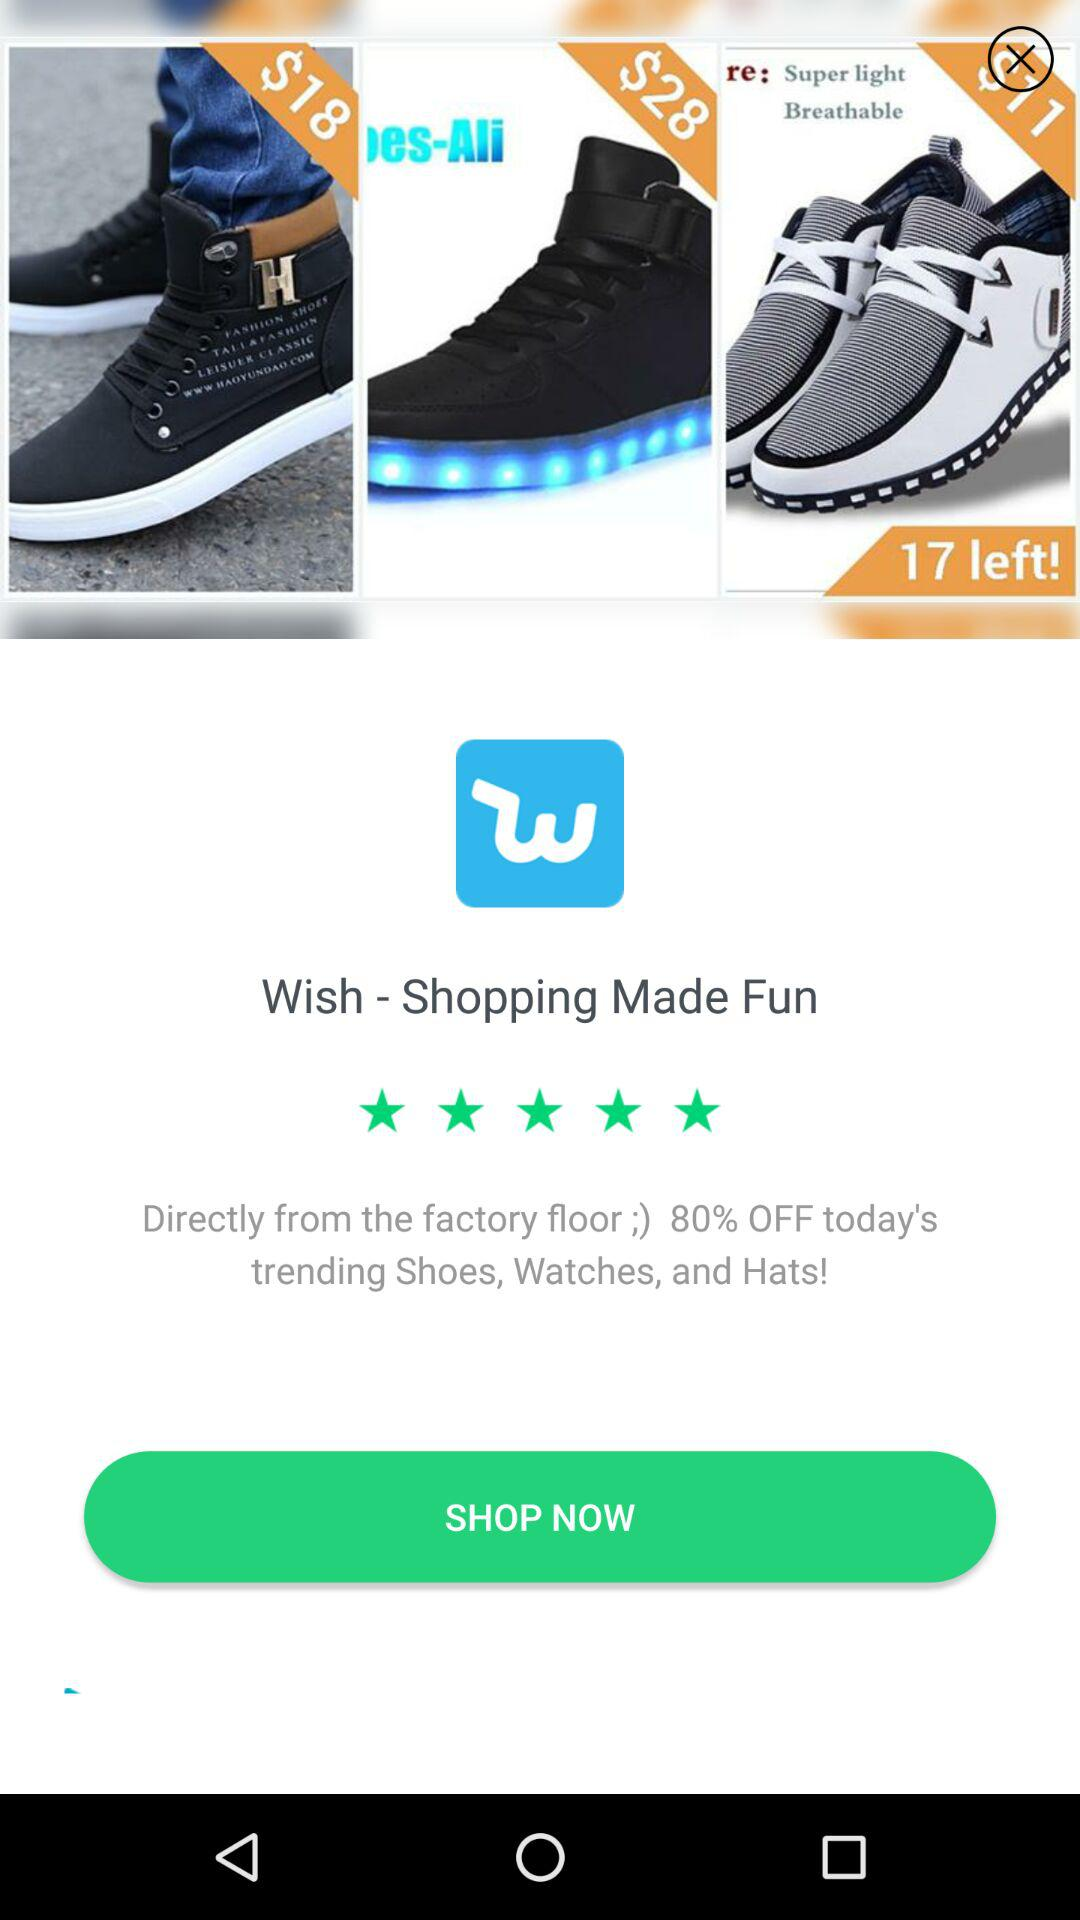What is the application name? The application name is "Wish - Shopping Made Fun". 